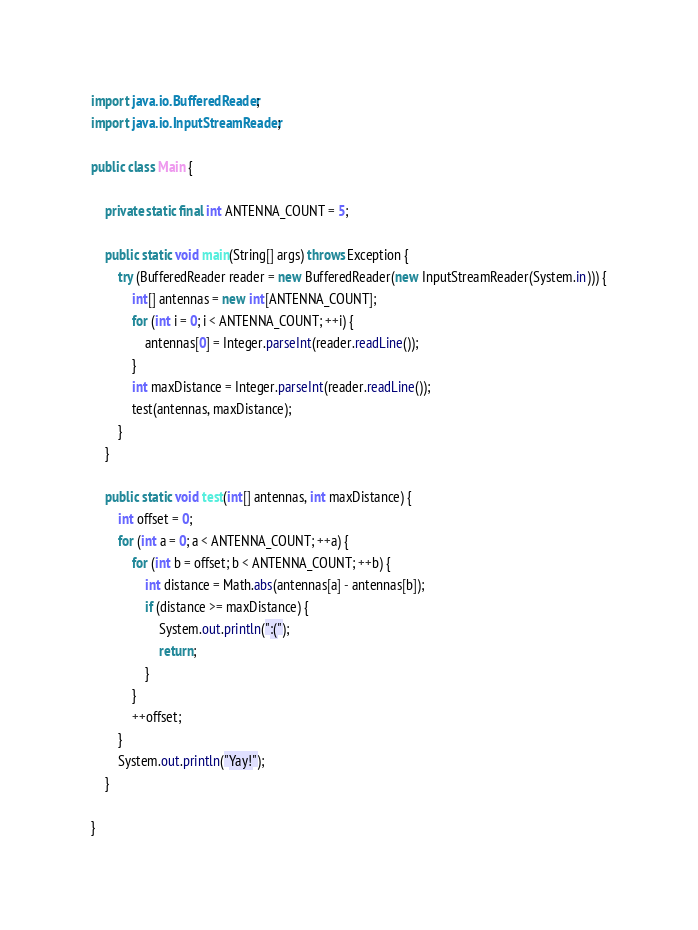<code> <loc_0><loc_0><loc_500><loc_500><_Java_>import java.io.BufferedReader;
import java.io.InputStreamReader;

public class Main {

    private static final int ANTENNA_COUNT = 5;

    public static void main(String[] args) throws Exception {
        try (BufferedReader reader = new BufferedReader(new InputStreamReader(System.in))) {
            int[] antennas = new int[ANTENNA_COUNT];
            for (int i = 0; i < ANTENNA_COUNT; ++i) {
                antennas[0] = Integer.parseInt(reader.readLine());
            }
            int maxDistance = Integer.parseInt(reader.readLine());
            test(antennas, maxDistance);
        }
    }

    public static void test(int[] antennas, int maxDistance) {
        int offset = 0;
        for (int a = 0; a < ANTENNA_COUNT; ++a) {
            for (int b = offset; b < ANTENNA_COUNT; ++b) {
                int distance = Math.abs(antennas[a] - antennas[b]);
                if (distance >= maxDistance) {
                    System.out.println(":(");
                    return;
                }
            }
            ++offset;
        }
        System.out.println("Yay!");
    }

}
</code> 